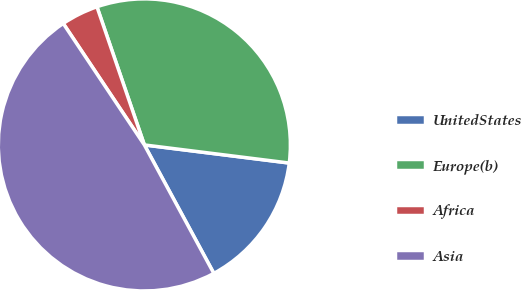<chart> <loc_0><loc_0><loc_500><loc_500><pie_chart><fcel>UnitedStates<fcel>Europe(b)<fcel>Africa<fcel>Asia<nl><fcel>15.13%<fcel>32.24%<fcel>4.11%<fcel>48.52%<nl></chart> 